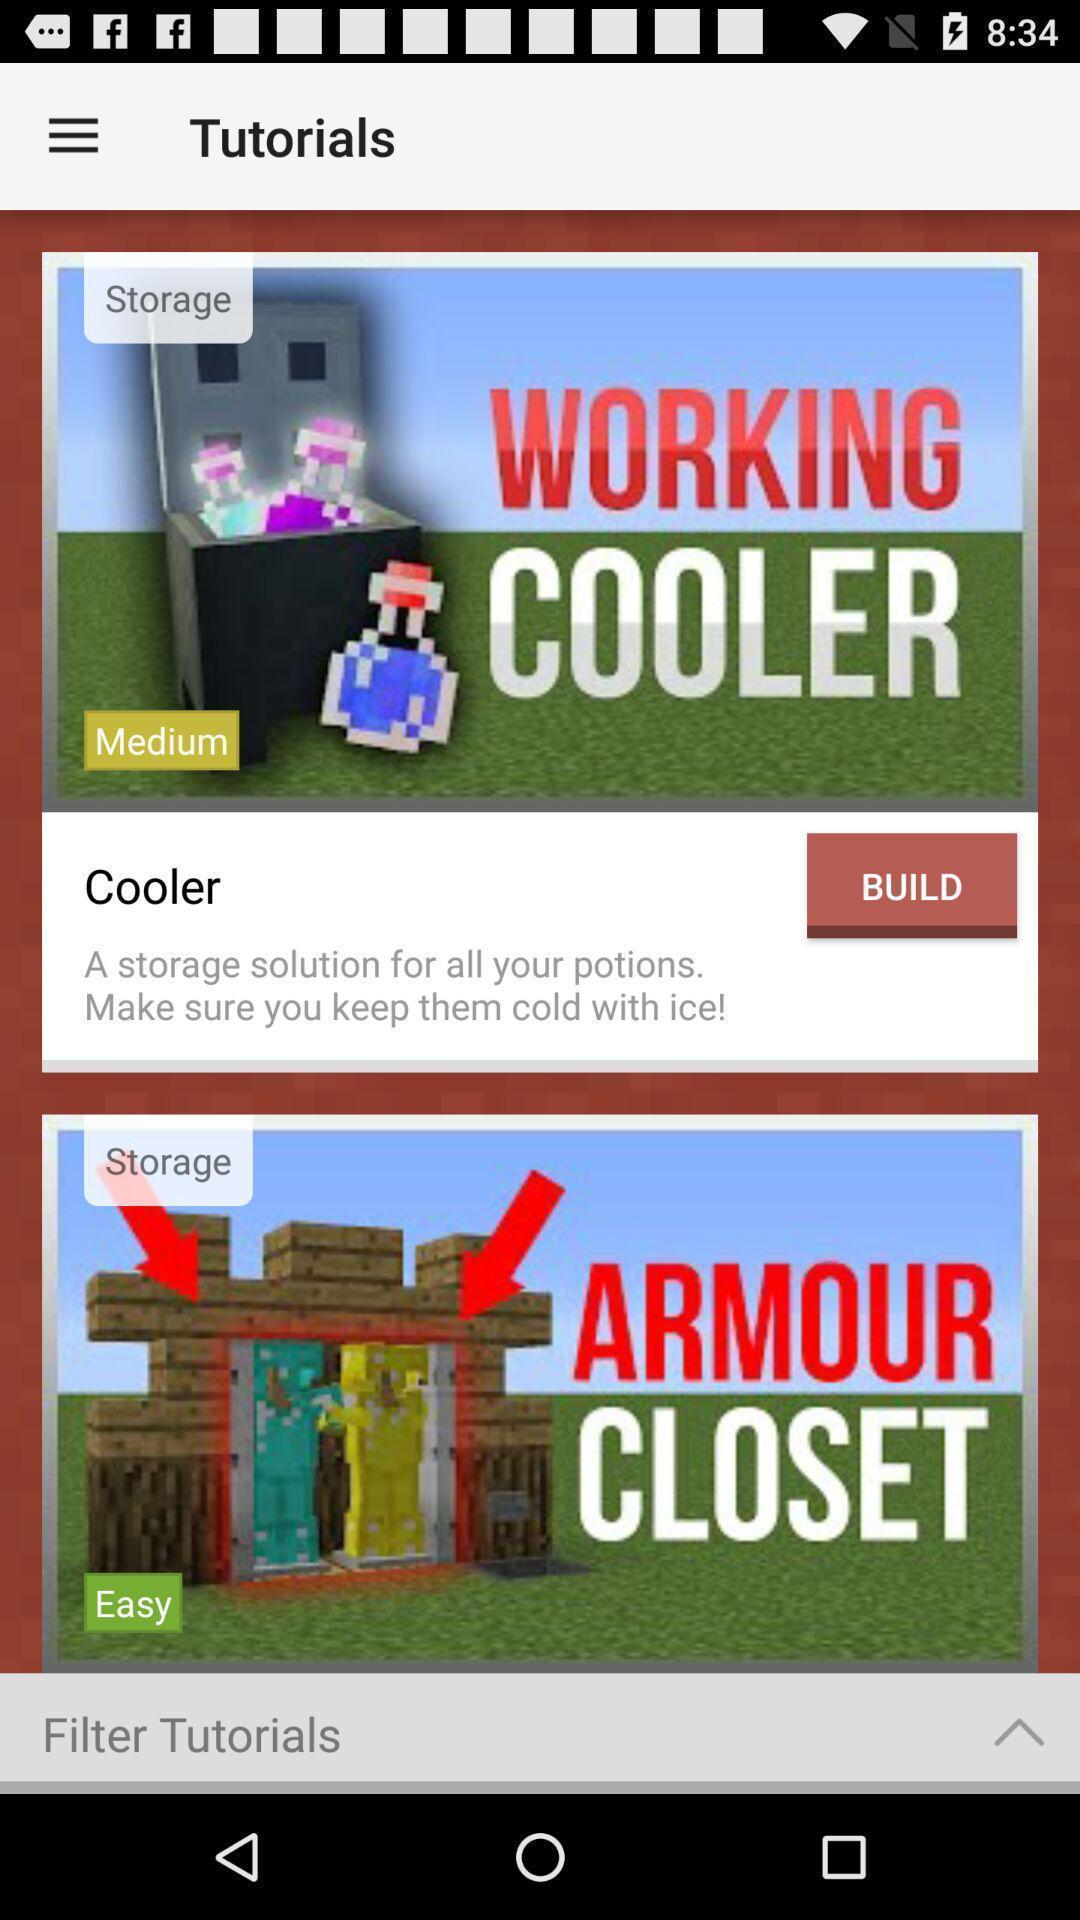Provide a detailed account of this screenshot. Screen displaying multiple tutorials on different topics. 